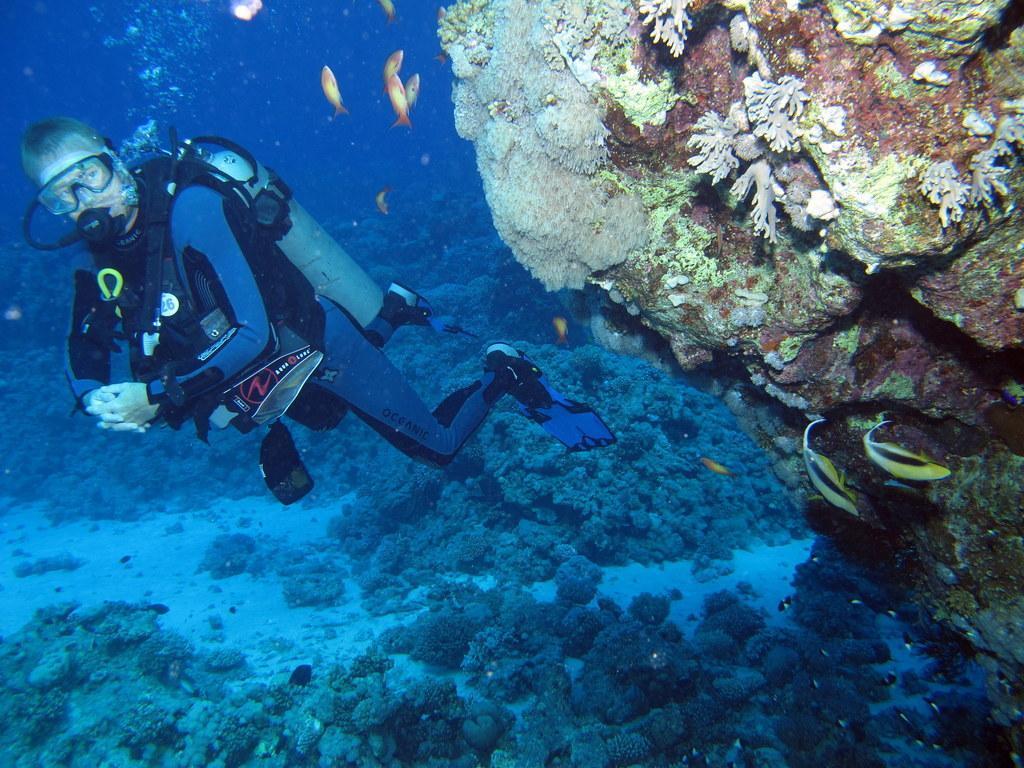Describe this image in one or two sentences. This is a water body and here we can see a person performing scuba diving and there are fishes and we can see rocks. 